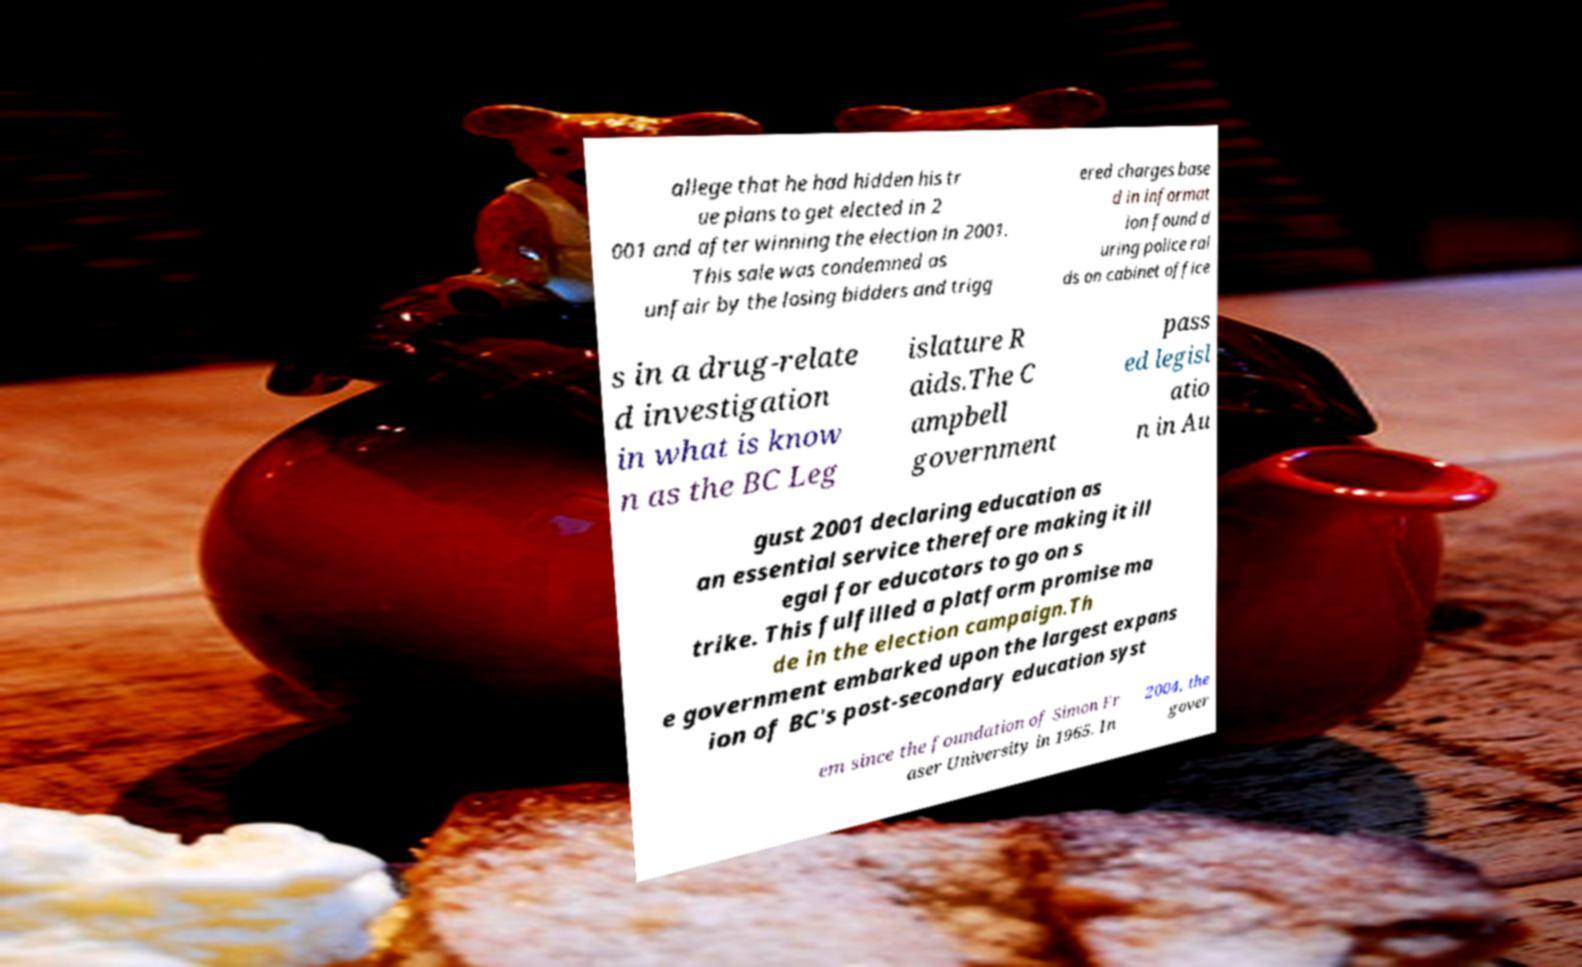Please identify and transcribe the text found in this image. allege that he had hidden his tr ue plans to get elected in 2 001 and after winning the election in 2001. This sale was condemned as unfair by the losing bidders and trigg ered charges base d in informat ion found d uring police rai ds on cabinet office s in a drug-relate d investigation in what is know n as the BC Leg islature R aids.The C ampbell government pass ed legisl atio n in Au gust 2001 declaring education as an essential service therefore making it ill egal for educators to go on s trike. This fulfilled a platform promise ma de in the election campaign.Th e government embarked upon the largest expans ion of BC's post-secondary education syst em since the foundation of Simon Fr aser University in 1965. In 2004, the gover 